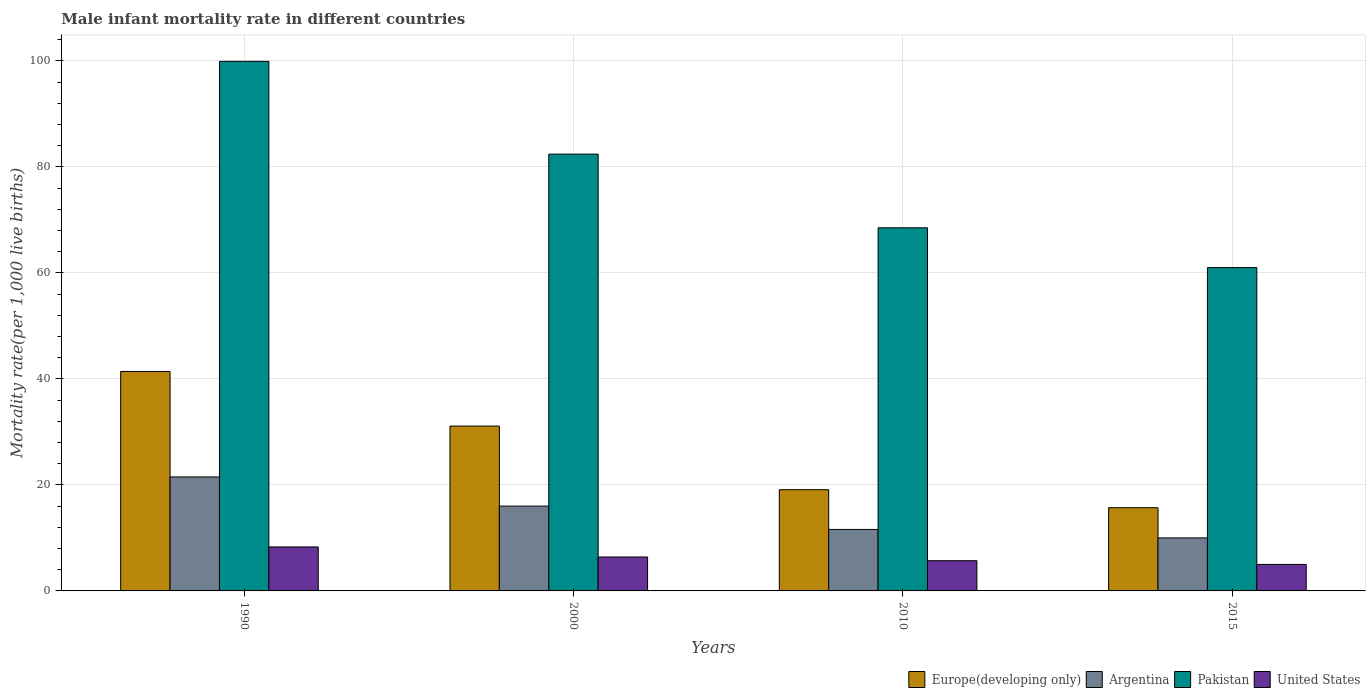Are the number of bars per tick equal to the number of legend labels?
Ensure brevity in your answer.  Yes. How many bars are there on the 2nd tick from the left?
Your answer should be compact. 4. How many bars are there on the 1st tick from the right?
Provide a short and direct response. 4. What is the label of the 4th group of bars from the left?
Ensure brevity in your answer.  2015. In how many cases, is the number of bars for a given year not equal to the number of legend labels?
Ensure brevity in your answer.  0. What is the male infant mortality rate in Pakistan in 2000?
Provide a succinct answer. 82.4. Across all years, what is the maximum male infant mortality rate in Europe(developing only)?
Give a very brief answer. 41.4. In which year was the male infant mortality rate in Argentina minimum?
Your answer should be compact. 2015. What is the total male infant mortality rate in United States in the graph?
Make the answer very short. 25.4. What is the difference between the male infant mortality rate in Pakistan in 1990 and that in 2000?
Your response must be concise. 17.5. What is the difference between the male infant mortality rate in Europe(developing only) in 2000 and the male infant mortality rate in Pakistan in 1990?
Provide a short and direct response. -68.8. What is the average male infant mortality rate in United States per year?
Keep it short and to the point. 6.35. In the year 2010, what is the difference between the male infant mortality rate in United States and male infant mortality rate in Argentina?
Your answer should be compact. -5.9. What is the ratio of the male infant mortality rate in Pakistan in 2000 to that in 2010?
Keep it short and to the point. 1.2. Is the difference between the male infant mortality rate in United States in 2000 and 2010 greater than the difference between the male infant mortality rate in Argentina in 2000 and 2010?
Give a very brief answer. No. What is the difference between the highest and the second highest male infant mortality rate in United States?
Give a very brief answer. 1.9. What is the difference between the highest and the lowest male infant mortality rate in Pakistan?
Offer a very short reply. 38.9. In how many years, is the male infant mortality rate in Argentina greater than the average male infant mortality rate in Argentina taken over all years?
Your answer should be compact. 2. Is the sum of the male infant mortality rate in United States in 1990 and 2010 greater than the maximum male infant mortality rate in Argentina across all years?
Give a very brief answer. No. Is it the case that in every year, the sum of the male infant mortality rate in United States and male infant mortality rate in Europe(developing only) is greater than the sum of male infant mortality rate in Pakistan and male infant mortality rate in Argentina?
Ensure brevity in your answer.  No. What does the 1st bar from the left in 2015 represents?
Offer a terse response. Europe(developing only). What does the 2nd bar from the right in 2000 represents?
Make the answer very short. Pakistan. Is it the case that in every year, the sum of the male infant mortality rate in Argentina and male infant mortality rate in Pakistan is greater than the male infant mortality rate in United States?
Provide a short and direct response. Yes. How many bars are there?
Ensure brevity in your answer.  16. How many years are there in the graph?
Your response must be concise. 4. Does the graph contain any zero values?
Keep it short and to the point. No. How many legend labels are there?
Offer a terse response. 4. How are the legend labels stacked?
Give a very brief answer. Horizontal. What is the title of the graph?
Provide a short and direct response. Male infant mortality rate in different countries. Does "Central African Republic" appear as one of the legend labels in the graph?
Keep it short and to the point. No. What is the label or title of the Y-axis?
Your answer should be very brief. Mortality rate(per 1,0 live births). What is the Mortality rate(per 1,000 live births) of Europe(developing only) in 1990?
Provide a short and direct response. 41.4. What is the Mortality rate(per 1,000 live births) of Argentina in 1990?
Ensure brevity in your answer.  21.5. What is the Mortality rate(per 1,000 live births) in Pakistan in 1990?
Provide a short and direct response. 99.9. What is the Mortality rate(per 1,000 live births) in United States in 1990?
Offer a terse response. 8.3. What is the Mortality rate(per 1,000 live births) of Europe(developing only) in 2000?
Make the answer very short. 31.1. What is the Mortality rate(per 1,000 live births) of Pakistan in 2000?
Offer a very short reply. 82.4. What is the Mortality rate(per 1,000 live births) in Europe(developing only) in 2010?
Your answer should be compact. 19.1. What is the Mortality rate(per 1,000 live births) of Argentina in 2010?
Your answer should be very brief. 11.6. What is the Mortality rate(per 1,000 live births) in Pakistan in 2010?
Your response must be concise. 68.5. What is the Mortality rate(per 1,000 live births) of Europe(developing only) in 2015?
Provide a succinct answer. 15.7. What is the Mortality rate(per 1,000 live births) of Argentina in 2015?
Make the answer very short. 10. What is the Mortality rate(per 1,000 live births) in Pakistan in 2015?
Keep it short and to the point. 61. What is the Mortality rate(per 1,000 live births) of United States in 2015?
Offer a very short reply. 5. Across all years, what is the maximum Mortality rate(per 1,000 live births) in Europe(developing only)?
Give a very brief answer. 41.4. Across all years, what is the maximum Mortality rate(per 1,000 live births) of Argentina?
Ensure brevity in your answer.  21.5. Across all years, what is the maximum Mortality rate(per 1,000 live births) in Pakistan?
Offer a terse response. 99.9. Across all years, what is the maximum Mortality rate(per 1,000 live births) of United States?
Give a very brief answer. 8.3. Across all years, what is the minimum Mortality rate(per 1,000 live births) in Europe(developing only)?
Your answer should be compact. 15.7. Across all years, what is the minimum Mortality rate(per 1,000 live births) in Pakistan?
Provide a succinct answer. 61. Across all years, what is the minimum Mortality rate(per 1,000 live births) in United States?
Your answer should be very brief. 5. What is the total Mortality rate(per 1,000 live births) in Europe(developing only) in the graph?
Offer a very short reply. 107.3. What is the total Mortality rate(per 1,000 live births) in Argentina in the graph?
Offer a terse response. 59.1. What is the total Mortality rate(per 1,000 live births) in Pakistan in the graph?
Ensure brevity in your answer.  311.8. What is the total Mortality rate(per 1,000 live births) in United States in the graph?
Offer a very short reply. 25.4. What is the difference between the Mortality rate(per 1,000 live births) of Europe(developing only) in 1990 and that in 2000?
Provide a succinct answer. 10.3. What is the difference between the Mortality rate(per 1,000 live births) in Argentina in 1990 and that in 2000?
Your response must be concise. 5.5. What is the difference between the Mortality rate(per 1,000 live births) in United States in 1990 and that in 2000?
Your response must be concise. 1.9. What is the difference between the Mortality rate(per 1,000 live births) of Europe(developing only) in 1990 and that in 2010?
Your answer should be very brief. 22.3. What is the difference between the Mortality rate(per 1,000 live births) in Argentina in 1990 and that in 2010?
Keep it short and to the point. 9.9. What is the difference between the Mortality rate(per 1,000 live births) in Pakistan in 1990 and that in 2010?
Your response must be concise. 31.4. What is the difference between the Mortality rate(per 1,000 live births) in Europe(developing only) in 1990 and that in 2015?
Your answer should be very brief. 25.7. What is the difference between the Mortality rate(per 1,000 live births) of Pakistan in 1990 and that in 2015?
Give a very brief answer. 38.9. What is the difference between the Mortality rate(per 1,000 live births) of Europe(developing only) in 2000 and that in 2010?
Keep it short and to the point. 12. What is the difference between the Mortality rate(per 1,000 live births) in Argentina in 2000 and that in 2010?
Offer a very short reply. 4.4. What is the difference between the Mortality rate(per 1,000 live births) in United States in 2000 and that in 2010?
Ensure brevity in your answer.  0.7. What is the difference between the Mortality rate(per 1,000 live births) of Europe(developing only) in 2000 and that in 2015?
Make the answer very short. 15.4. What is the difference between the Mortality rate(per 1,000 live births) in Pakistan in 2000 and that in 2015?
Make the answer very short. 21.4. What is the difference between the Mortality rate(per 1,000 live births) of Europe(developing only) in 1990 and the Mortality rate(per 1,000 live births) of Argentina in 2000?
Provide a short and direct response. 25.4. What is the difference between the Mortality rate(per 1,000 live births) in Europe(developing only) in 1990 and the Mortality rate(per 1,000 live births) in Pakistan in 2000?
Ensure brevity in your answer.  -41. What is the difference between the Mortality rate(per 1,000 live births) in Europe(developing only) in 1990 and the Mortality rate(per 1,000 live births) in United States in 2000?
Offer a very short reply. 35. What is the difference between the Mortality rate(per 1,000 live births) in Argentina in 1990 and the Mortality rate(per 1,000 live births) in Pakistan in 2000?
Provide a short and direct response. -60.9. What is the difference between the Mortality rate(per 1,000 live births) of Argentina in 1990 and the Mortality rate(per 1,000 live births) of United States in 2000?
Keep it short and to the point. 15.1. What is the difference between the Mortality rate(per 1,000 live births) in Pakistan in 1990 and the Mortality rate(per 1,000 live births) in United States in 2000?
Give a very brief answer. 93.5. What is the difference between the Mortality rate(per 1,000 live births) in Europe(developing only) in 1990 and the Mortality rate(per 1,000 live births) in Argentina in 2010?
Make the answer very short. 29.8. What is the difference between the Mortality rate(per 1,000 live births) in Europe(developing only) in 1990 and the Mortality rate(per 1,000 live births) in Pakistan in 2010?
Provide a short and direct response. -27.1. What is the difference between the Mortality rate(per 1,000 live births) of Europe(developing only) in 1990 and the Mortality rate(per 1,000 live births) of United States in 2010?
Your answer should be compact. 35.7. What is the difference between the Mortality rate(per 1,000 live births) of Argentina in 1990 and the Mortality rate(per 1,000 live births) of Pakistan in 2010?
Make the answer very short. -47. What is the difference between the Mortality rate(per 1,000 live births) of Argentina in 1990 and the Mortality rate(per 1,000 live births) of United States in 2010?
Keep it short and to the point. 15.8. What is the difference between the Mortality rate(per 1,000 live births) in Pakistan in 1990 and the Mortality rate(per 1,000 live births) in United States in 2010?
Ensure brevity in your answer.  94.2. What is the difference between the Mortality rate(per 1,000 live births) of Europe(developing only) in 1990 and the Mortality rate(per 1,000 live births) of Argentina in 2015?
Make the answer very short. 31.4. What is the difference between the Mortality rate(per 1,000 live births) of Europe(developing only) in 1990 and the Mortality rate(per 1,000 live births) of Pakistan in 2015?
Offer a terse response. -19.6. What is the difference between the Mortality rate(per 1,000 live births) of Europe(developing only) in 1990 and the Mortality rate(per 1,000 live births) of United States in 2015?
Your response must be concise. 36.4. What is the difference between the Mortality rate(per 1,000 live births) in Argentina in 1990 and the Mortality rate(per 1,000 live births) in Pakistan in 2015?
Provide a short and direct response. -39.5. What is the difference between the Mortality rate(per 1,000 live births) of Pakistan in 1990 and the Mortality rate(per 1,000 live births) of United States in 2015?
Provide a short and direct response. 94.9. What is the difference between the Mortality rate(per 1,000 live births) in Europe(developing only) in 2000 and the Mortality rate(per 1,000 live births) in Pakistan in 2010?
Offer a terse response. -37.4. What is the difference between the Mortality rate(per 1,000 live births) of Europe(developing only) in 2000 and the Mortality rate(per 1,000 live births) of United States in 2010?
Keep it short and to the point. 25.4. What is the difference between the Mortality rate(per 1,000 live births) in Argentina in 2000 and the Mortality rate(per 1,000 live births) in Pakistan in 2010?
Provide a succinct answer. -52.5. What is the difference between the Mortality rate(per 1,000 live births) of Argentina in 2000 and the Mortality rate(per 1,000 live births) of United States in 2010?
Give a very brief answer. 10.3. What is the difference between the Mortality rate(per 1,000 live births) of Pakistan in 2000 and the Mortality rate(per 1,000 live births) of United States in 2010?
Your answer should be very brief. 76.7. What is the difference between the Mortality rate(per 1,000 live births) in Europe(developing only) in 2000 and the Mortality rate(per 1,000 live births) in Argentina in 2015?
Your response must be concise. 21.1. What is the difference between the Mortality rate(per 1,000 live births) in Europe(developing only) in 2000 and the Mortality rate(per 1,000 live births) in Pakistan in 2015?
Provide a short and direct response. -29.9. What is the difference between the Mortality rate(per 1,000 live births) of Europe(developing only) in 2000 and the Mortality rate(per 1,000 live births) of United States in 2015?
Offer a terse response. 26.1. What is the difference between the Mortality rate(per 1,000 live births) of Argentina in 2000 and the Mortality rate(per 1,000 live births) of Pakistan in 2015?
Your answer should be very brief. -45. What is the difference between the Mortality rate(per 1,000 live births) in Pakistan in 2000 and the Mortality rate(per 1,000 live births) in United States in 2015?
Offer a terse response. 77.4. What is the difference between the Mortality rate(per 1,000 live births) of Europe(developing only) in 2010 and the Mortality rate(per 1,000 live births) of Argentina in 2015?
Your answer should be very brief. 9.1. What is the difference between the Mortality rate(per 1,000 live births) in Europe(developing only) in 2010 and the Mortality rate(per 1,000 live births) in Pakistan in 2015?
Give a very brief answer. -41.9. What is the difference between the Mortality rate(per 1,000 live births) in Argentina in 2010 and the Mortality rate(per 1,000 live births) in Pakistan in 2015?
Make the answer very short. -49.4. What is the difference between the Mortality rate(per 1,000 live births) in Pakistan in 2010 and the Mortality rate(per 1,000 live births) in United States in 2015?
Offer a terse response. 63.5. What is the average Mortality rate(per 1,000 live births) in Europe(developing only) per year?
Your answer should be very brief. 26.82. What is the average Mortality rate(per 1,000 live births) of Argentina per year?
Offer a terse response. 14.78. What is the average Mortality rate(per 1,000 live births) of Pakistan per year?
Your answer should be very brief. 77.95. What is the average Mortality rate(per 1,000 live births) of United States per year?
Provide a short and direct response. 6.35. In the year 1990, what is the difference between the Mortality rate(per 1,000 live births) in Europe(developing only) and Mortality rate(per 1,000 live births) in Pakistan?
Offer a very short reply. -58.5. In the year 1990, what is the difference between the Mortality rate(per 1,000 live births) in Europe(developing only) and Mortality rate(per 1,000 live births) in United States?
Keep it short and to the point. 33.1. In the year 1990, what is the difference between the Mortality rate(per 1,000 live births) of Argentina and Mortality rate(per 1,000 live births) of Pakistan?
Keep it short and to the point. -78.4. In the year 1990, what is the difference between the Mortality rate(per 1,000 live births) in Pakistan and Mortality rate(per 1,000 live births) in United States?
Offer a very short reply. 91.6. In the year 2000, what is the difference between the Mortality rate(per 1,000 live births) of Europe(developing only) and Mortality rate(per 1,000 live births) of Pakistan?
Offer a very short reply. -51.3. In the year 2000, what is the difference between the Mortality rate(per 1,000 live births) in Europe(developing only) and Mortality rate(per 1,000 live births) in United States?
Provide a succinct answer. 24.7. In the year 2000, what is the difference between the Mortality rate(per 1,000 live births) in Argentina and Mortality rate(per 1,000 live births) in Pakistan?
Provide a succinct answer. -66.4. In the year 2000, what is the difference between the Mortality rate(per 1,000 live births) of Argentina and Mortality rate(per 1,000 live births) of United States?
Your answer should be very brief. 9.6. In the year 2010, what is the difference between the Mortality rate(per 1,000 live births) of Europe(developing only) and Mortality rate(per 1,000 live births) of Argentina?
Offer a very short reply. 7.5. In the year 2010, what is the difference between the Mortality rate(per 1,000 live births) in Europe(developing only) and Mortality rate(per 1,000 live births) in Pakistan?
Your answer should be compact. -49.4. In the year 2010, what is the difference between the Mortality rate(per 1,000 live births) of Europe(developing only) and Mortality rate(per 1,000 live births) of United States?
Ensure brevity in your answer.  13.4. In the year 2010, what is the difference between the Mortality rate(per 1,000 live births) of Argentina and Mortality rate(per 1,000 live births) of Pakistan?
Provide a succinct answer. -56.9. In the year 2010, what is the difference between the Mortality rate(per 1,000 live births) of Pakistan and Mortality rate(per 1,000 live births) of United States?
Provide a short and direct response. 62.8. In the year 2015, what is the difference between the Mortality rate(per 1,000 live births) of Europe(developing only) and Mortality rate(per 1,000 live births) of Argentina?
Ensure brevity in your answer.  5.7. In the year 2015, what is the difference between the Mortality rate(per 1,000 live births) of Europe(developing only) and Mortality rate(per 1,000 live births) of Pakistan?
Your response must be concise. -45.3. In the year 2015, what is the difference between the Mortality rate(per 1,000 live births) in Europe(developing only) and Mortality rate(per 1,000 live births) in United States?
Provide a short and direct response. 10.7. In the year 2015, what is the difference between the Mortality rate(per 1,000 live births) in Argentina and Mortality rate(per 1,000 live births) in Pakistan?
Give a very brief answer. -51. In the year 2015, what is the difference between the Mortality rate(per 1,000 live births) of Pakistan and Mortality rate(per 1,000 live births) of United States?
Give a very brief answer. 56. What is the ratio of the Mortality rate(per 1,000 live births) of Europe(developing only) in 1990 to that in 2000?
Your answer should be compact. 1.33. What is the ratio of the Mortality rate(per 1,000 live births) of Argentina in 1990 to that in 2000?
Your response must be concise. 1.34. What is the ratio of the Mortality rate(per 1,000 live births) in Pakistan in 1990 to that in 2000?
Offer a very short reply. 1.21. What is the ratio of the Mortality rate(per 1,000 live births) of United States in 1990 to that in 2000?
Give a very brief answer. 1.3. What is the ratio of the Mortality rate(per 1,000 live births) of Europe(developing only) in 1990 to that in 2010?
Your answer should be compact. 2.17. What is the ratio of the Mortality rate(per 1,000 live births) in Argentina in 1990 to that in 2010?
Offer a terse response. 1.85. What is the ratio of the Mortality rate(per 1,000 live births) in Pakistan in 1990 to that in 2010?
Your answer should be compact. 1.46. What is the ratio of the Mortality rate(per 1,000 live births) of United States in 1990 to that in 2010?
Your answer should be compact. 1.46. What is the ratio of the Mortality rate(per 1,000 live births) of Europe(developing only) in 1990 to that in 2015?
Make the answer very short. 2.64. What is the ratio of the Mortality rate(per 1,000 live births) of Argentina in 1990 to that in 2015?
Your answer should be very brief. 2.15. What is the ratio of the Mortality rate(per 1,000 live births) of Pakistan in 1990 to that in 2015?
Give a very brief answer. 1.64. What is the ratio of the Mortality rate(per 1,000 live births) of United States in 1990 to that in 2015?
Your response must be concise. 1.66. What is the ratio of the Mortality rate(per 1,000 live births) in Europe(developing only) in 2000 to that in 2010?
Make the answer very short. 1.63. What is the ratio of the Mortality rate(per 1,000 live births) in Argentina in 2000 to that in 2010?
Your response must be concise. 1.38. What is the ratio of the Mortality rate(per 1,000 live births) of Pakistan in 2000 to that in 2010?
Your answer should be very brief. 1.2. What is the ratio of the Mortality rate(per 1,000 live births) of United States in 2000 to that in 2010?
Keep it short and to the point. 1.12. What is the ratio of the Mortality rate(per 1,000 live births) in Europe(developing only) in 2000 to that in 2015?
Make the answer very short. 1.98. What is the ratio of the Mortality rate(per 1,000 live births) of Pakistan in 2000 to that in 2015?
Provide a succinct answer. 1.35. What is the ratio of the Mortality rate(per 1,000 live births) of United States in 2000 to that in 2015?
Ensure brevity in your answer.  1.28. What is the ratio of the Mortality rate(per 1,000 live births) in Europe(developing only) in 2010 to that in 2015?
Offer a very short reply. 1.22. What is the ratio of the Mortality rate(per 1,000 live births) in Argentina in 2010 to that in 2015?
Ensure brevity in your answer.  1.16. What is the ratio of the Mortality rate(per 1,000 live births) in Pakistan in 2010 to that in 2015?
Give a very brief answer. 1.12. What is the ratio of the Mortality rate(per 1,000 live births) of United States in 2010 to that in 2015?
Provide a succinct answer. 1.14. What is the difference between the highest and the second highest Mortality rate(per 1,000 live births) in Europe(developing only)?
Make the answer very short. 10.3. What is the difference between the highest and the second highest Mortality rate(per 1,000 live births) of Pakistan?
Keep it short and to the point. 17.5. What is the difference between the highest and the second highest Mortality rate(per 1,000 live births) of United States?
Offer a very short reply. 1.9. What is the difference between the highest and the lowest Mortality rate(per 1,000 live births) of Europe(developing only)?
Provide a short and direct response. 25.7. What is the difference between the highest and the lowest Mortality rate(per 1,000 live births) in Argentina?
Make the answer very short. 11.5. What is the difference between the highest and the lowest Mortality rate(per 1,000 live births) of Pakistan?
Keep it short and to the point. 38.9. 